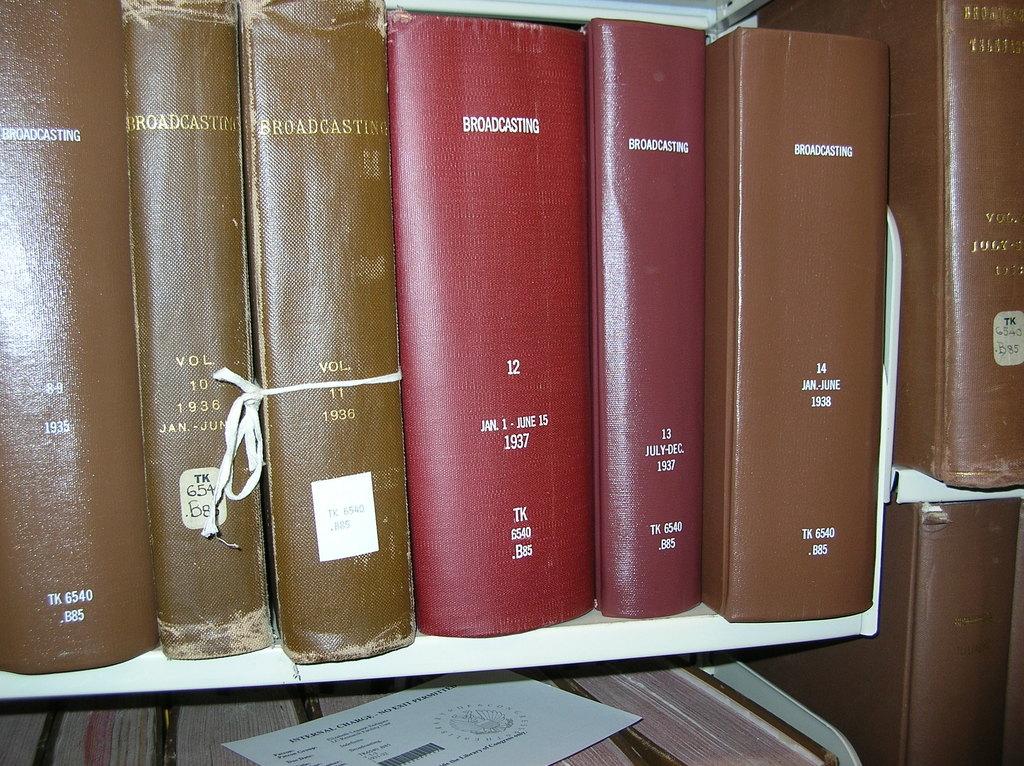What color is the largest book?
Provide a succinct answer. Answering does not require reading text in the image. What is the title of the red book in the middle?
Provide a succinct answer. Broadcasting. 